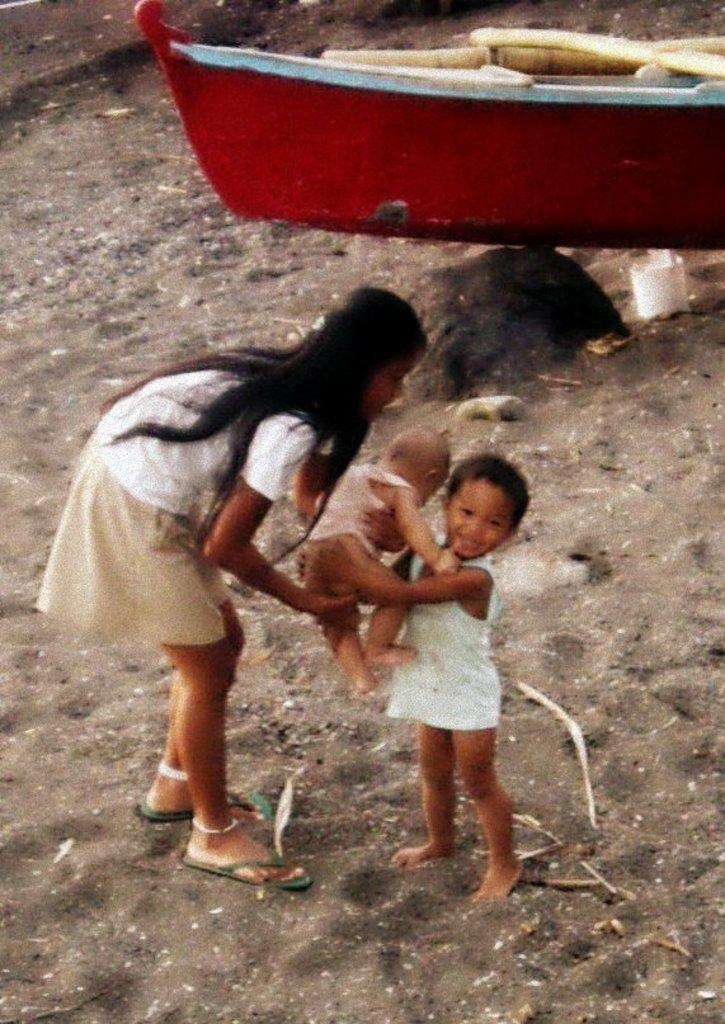What is the main subject in the center of the image? There is a boy standing in the center of the image. What is the boy doing in the image? The boy is holding a baby in his hand. Who is standing next to the boy? There is a girl next to the boy. What can be seen in the background of the image? There is a boat in the background of the image. What type of surface is at the bottom of the image? There is sand at the bottom of the image. How many trains can be seen in the image? There are no trains present in the image. Is there any snow visible in the image? No, there is no snow visible in the image. 